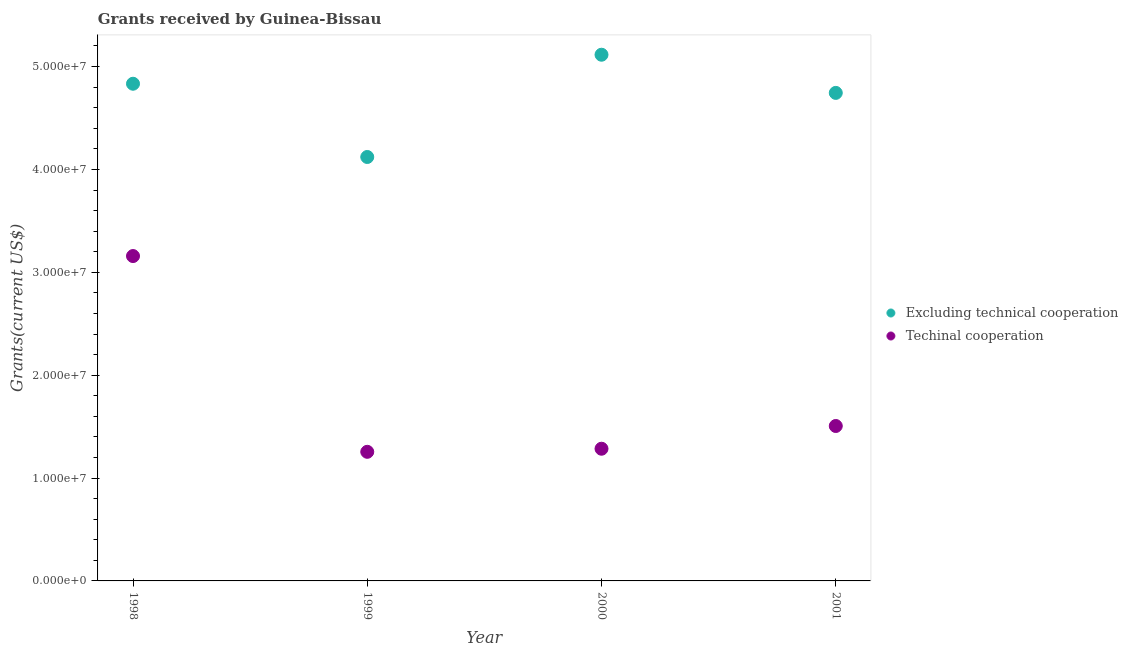Is the number of dotlines equal to the number of legend labels?
Your answer should be very brief. Yes. What is the amount of grants received(including technical cooperation) in 1998?
Ensure brevity in your answer.  3.16e+07. Across all years, what is the maximum amount of grants received(excluding technical cooperation)?
Your answer should be compact. 5.12e+07. Across all years, what is the minimum amount of grants received(including technical cooperation)?
Offer a very short reply. 1.26e+07. In which year was the amount of grants received(including technical cooperation) minimum?
Ensure brevity in your answer.  1999. What is the total amount of grants received(excluding technical cooperation) in the graph?
Your response must be concise. 1.88e+08. What is the difference between the amount of grants received(including technical cooperation) in 1999 and that in 2000?
Provide a succinct answer. -3.00e+05. What is the difference between the amount of grants received(excluding technical cooperation) in 2000 and the amount of grants received(including technical cooperation) in 1998?
Offer a very short reply. 1.96e+07. What is the average amount of grants received(including technical cooperation) per year?
Provide a short and direct response. 1.80e+07. In the year 2000, what is the difference between the amount of grants received(including technical cooperation) and amount of grants received(excluding technical cooperation)?
Provide a succinct answer. -3.83e+07. What is the ratio of the amount of grants received(excluding technical cooperation) in 1998 to that in 2001?
Your answer should be compact. 1.02. Is the amount of grants received(excluding technical cooperation) in 1999 less than that in 2001?
Your answer should be very brief. Yes. What is the difference between the highest and the second highest amount of grants received(including technical cooperation)?
Keep it short and to the point. 1.65e+07. What is the difference between the highest and the lowest amount of grants received(including technical cooperation)?
Your answer should be compact. 1.90e+07. How many dotlines are there?
Keep it short and to the point. 2. How many years are there in the graph?
Give a very brief answer. 4. Does the graph contain any zero values?
Provide a short and direct response. No. Does the graph contain grids?
Make the answer very short. No. Where does the legend appear in the graph?
Offer a very short reply. Center right. How many legend labels are there?
Give a very brief answer. 2. How are the legend labels stacked?
Your answer should be very brief. Vertical. What is the title of the graph?
Ensure brevity in your answer.  Grants received by Guinea-Bissau. What is the label or title of the X-axis?
Keep it short and to the point. Year. What is the label or title of the Y-axis?
Offer a very short reply. Grants(current US$). What is the Grants(current US$) of Excluding technical cooperation in 1998?
Provide a succinct answer. 4.83e+07. What is the Grants(current US$) in Techinal cooperation in 1998?
Keep it short and to the point. 3.16e+07. What is the Grants(current US$) in Excluding technical cooperation in 1999?
Provide a succinct answer. 4.12e+07. What is the Grants(current US$) of Techinal cooperation in 1999?
Your answer should be very brief. 1.26e+07. What is the Grants(current US$) in Excluding technical cooperation in 2000?
Ensure brevity in your answer.  5.12e+07. What is the Grants(current US$) in Techinal cooperation in 2000?
Ensure brevity in your answer.  1.28e+07. What is the Grants(current US$) in Excluding technical cooperation in 2001?
Your answer should be compact. 4.74e+07. What is the Grants(current US$) of Techinal cooperation in 2001?
Give a very brief answer. 1.51e+07. Across all years, what is the maximum Grants(current US$) of Excluding technical cooperation?
Your answer should be compact. 5.12e+07. Across all years, what is the maximum Grants(current US$) in Techinal cooperation?
Ensure brevity in your answer.  3.16e+07. Across all years, what is the minimum Grants(current US$) of Excluding technical cooperation?
Your answer should be very brief. 4.12e+07. Across all years, what is the minimum Grants(current US$) in Techinal cooperation?
Offer a terse response. 1.26e+07. What is the total Grants(current US$) in Excluding technical cooperation in the graph?
Keep it short and to the point. 1.88e+08. What is the total Grants(current US$) of Techinal cooperation in the graph?
Your answer should be very brief. 7.20e+07. What is the difference between the Grants(current US$) of Excluding technical cooperation in 1998 and that in 1999?
Give a very brief answer. 7.12e+06. What is the difference between the Grants(current US$) of Techinal cooperation in 1998 and that in 1999?
Your answer should be very brief. 1.90e+07. What is the difference between the Grants(current US$) in Excluding technical cooperation in 1998 and that in 2000?
Keep it short and to the point. -2.82e+06. What is the difference between the Grants(current US$) of Techinal cooperation in 1998 and that in 2000?
Offer a terse response. 1.87e+07. What is the difference between the Grants(current US$) of Excluding technical cooperation in 1998 and that in 2001?
Provide a short and direct response. 8.90e+05. What is the difference between the Grants(current US$) in Techinal cooperation in 1998 and that in 2001?
Your answer should be compact. 1.65e+07. What is the difference between the Grants(current US$) of Excluding technical cooperation in 1999 and that in 2000?
Provide a succinct answer. -9.94e+06. What is the difference between the Grants(current US$) of Excluding technical cooperation in 1999 and that in 2001?
Make the answer very short. -6.23e+06. What is the difference between the Grants(current US$) in Techinal cooperation in 1999 and that in 2001?
Ensure brevity in your answer.  -2.51e+06. What is the difference between the Grants(current US$) in Excluding technical cooperation in 2000 and that in 2001?
Provide a succinct answer. 3.71e+06. What is the difference between the Grants(current US$) of Techinal cooperation in 2000 and that in 2001?
Your answer should be very brief. -2.21e+06. What is the difference between the Grants(current US$) in Excluding technical cooperation in 1998 and the Grants(current US$) in Techinal cooperation in 1999?
Provide a succinct answer. 3.58e+07. What is the difference between the Grants(current US$) in Excluding technical cooperation in 1998 and the Grants(current US$) in Techinal cooperation in 2000?
Ensure brevity in your answer.  3.55e+07. What is the difference between the Grants(current US$) in Excluding technical cooperation in 1998 and the Grants(current US$) in Techinal cooperation in 2001?
Offer a terse response. 3.33e+07. What is the difference between the Grants(current US$) in Excluding technical cooperation in 1999 and the Grants(current US$) in Techinal cooperation in 2000?
Your answer should be very brief. 2.84e+07. What is the difference between the Grants(current US$) of Excluding technical cooperation in 1999 and the Grants(current US$) of Techinal cooperation in 2001?
Make the answer very short. 2.62e+07. What is the difference between the Grants(current US$) of Excluding technical cooperation in 2000 and the Grants(current US$) of Techinal cooperation in 2001?
Keep it short and to the point. 3.61e+07. What is the average Grants(current US$) of Excluding technical cooperation per year?
Offer a very short reply. 4.70e+07. What is the average Grants(current US$) in Techinal cooperation per year?
Your answer should be compact. 1.80e+07. In the year 1998, what is the difference between the Grants(current US$) of Excluding technical cooperation and Grants(current US$) of Techinal cooperation?
Give a very brief answer. 1.68e+07. In the year 1999, what is the difference between the Grants(current US$) in Excluding technical cooperation and Grants(current US$) in Techinal cooperation?
Make the answer very short. 2.87e+07. In the year 2000, what is the difference between the Grants(current US$) of Excluding technical cooperation and Grants(current US$) of Techinal cooperation?
Your answer should be very brief. 3.83e+07. In the year 2001, what is the difference between the Grants(current US$) of Excluding technical cooperation and Grants(current US$) of Techinal cooperation?
Make the answer very short. 3.24e+07. What is the ratio of the Grants(current US$) of Excluding technical cooperation in 1998 to that in 1999?
Provide a succinct answer. 1.17. What is the ratio of the Grants(current US$) in Techinal cooperation in 1998 to that in 1999?
Give a very brief answer. 2.52. What is the ratio of the Grants(current US$) of Excluding technical cooperation in 1998 to that in 2000?
Ensure brevity in your answer.  0.94. What is the ratio of the Grants(current US$) of Techinal cooperation in 1998 to that in 2000?
Provide a succinct answer. 2.46. What is the ratio of the Grants(current US$) of Excluding technical cooperation in 1998 to that in 2001?
Provide a short and direct response. 1.02. What is the ratio of the Grants(current US$) of Techinal cooperation in 1998 to that in 2001?
Provide a succinct answer. 2.1. What is the ratio of the Grants(current US$) in Excluding technical cooperation in 1999 to that in 2000?
Give a very brief answer. 0.81. What is the ratio of the Grants(current US$) of Techinal cooperation in 1999 to that in 2000?
Offer a terse response. 0.98. What is the ratio of the Grants(current US$) in Excluding technical cooperation in 1999 to that in 2001?
Ensure brevity in your answer.  0.87. What is the ratio of the Grants(current US$) in Excluding technical cooperation in 2000 to that in 2001?
Ensure brevity in your answer.  1.08. What is the ratio of the Grants(current US$) of Techinal cooperation in 2000 to that in 2001?
Provide a short and direct response. 0.85. What is the difference between the highest and the second highest Grants(current US$) of Excluding technical cooperation?
Your answer should be compact. 2.82e+06. What is the difference between the highest and the second highest Grants(current US$) of Techinal cooperation?
Offer a very short reply. 1.65e+07. What is the difference between the highest and the lowest Grants(current US$) of Excluding technical cooperation?
Your answer should be very brief. 9.94e+06. What is the difference between the highest and the lowest Grants(current US$) of Techinal cooperation?
Your response must be concise. 1.90e+07. 